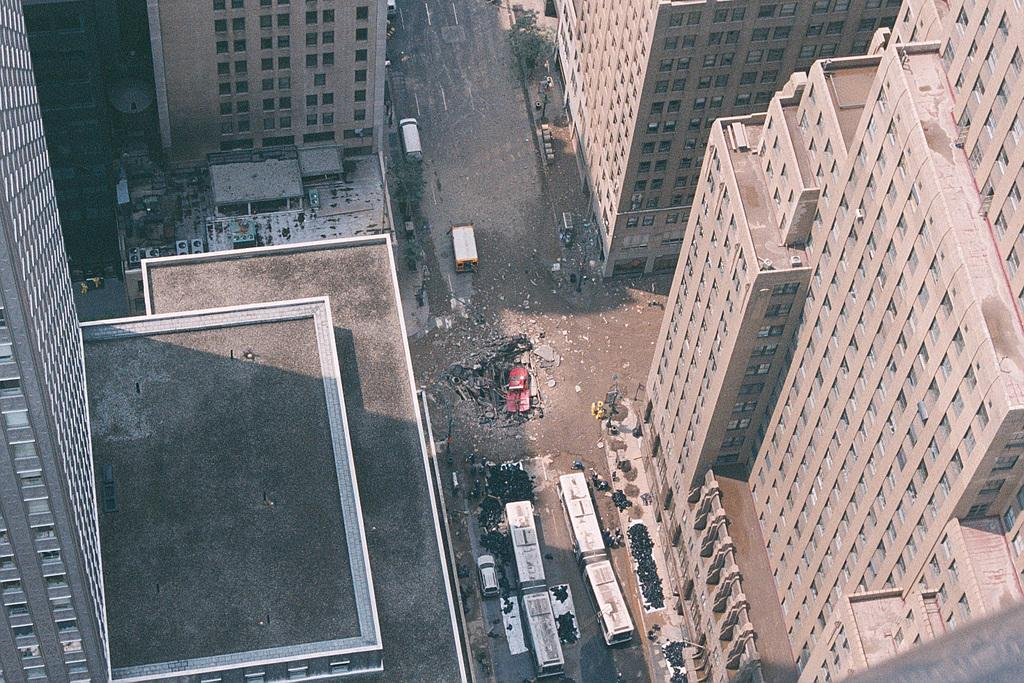What type of structures can be seen in the image? There are buildings in the image. What else is present in the image besides buildings? There are vehicles and a tree in the image. What is the surface that the vehicles are on? There is a road in the image. How many brothers are shaking the linen in the image? There are no brothers or linen present in the image. 